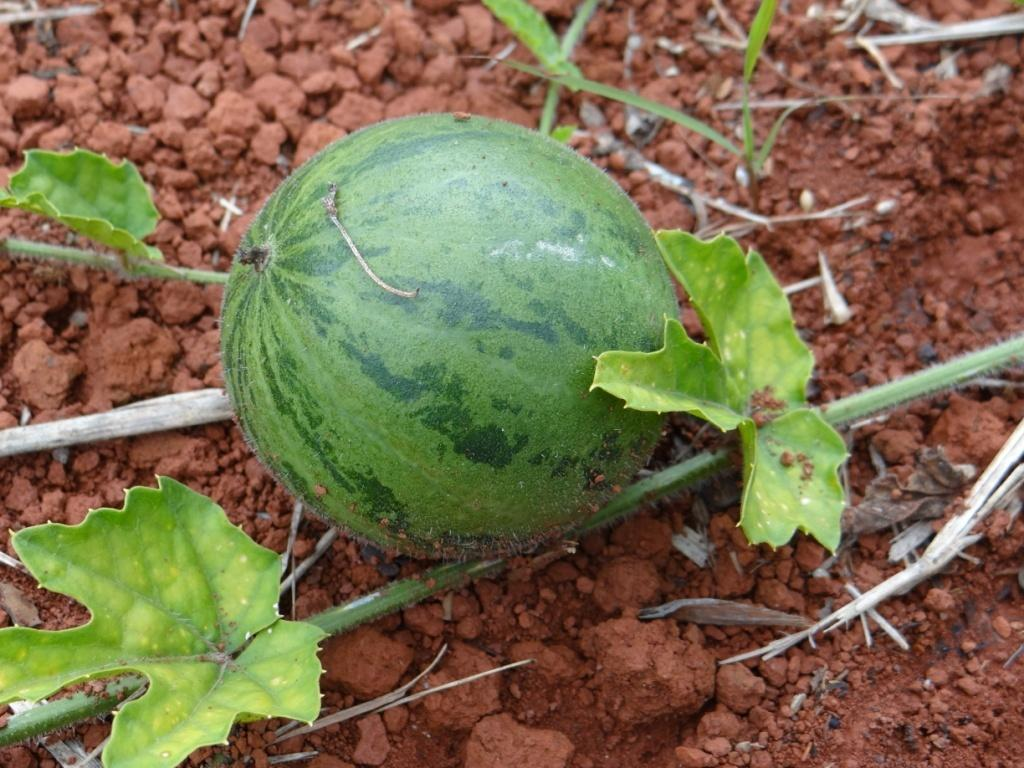What type of food item is present in the image? There is a fruit in the image. Where is the fruit located? The fruit is placed on the land. What else can be seen in the image besides the fruit in the image? There are leaves and a stick in the image. What type of drug is being used with the fruit in the image? There is no drug present in the image; it features a fruit placed on the land with leaves and a stick nearby. 